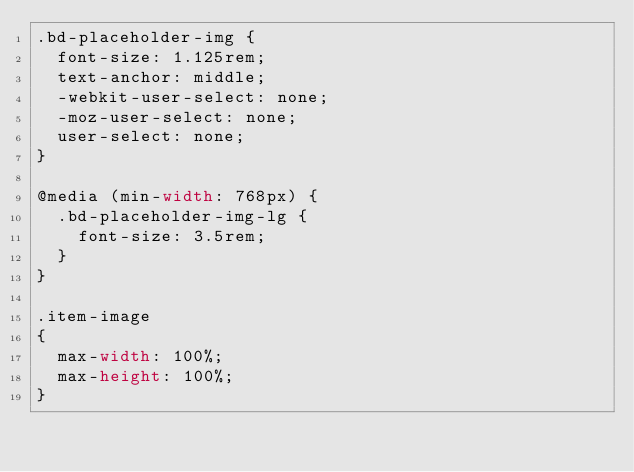<code> <loc_0><loc_0><loc_500><loc_500><_CSS_>.bd-placeholder-img {
  font-size: 1.125rem;
  text-anchor: middle;
  -webkit-user-select: none;
  -moz-user-select: none;
  user-select: none;
}

@media (min-width: 768px) {
  .bd-placeholder-img-lg {
    font-size: 3.5rem;
  }
}

.item-image
{
  max-width: 100%;
  max-height: 100%;
}</code> 